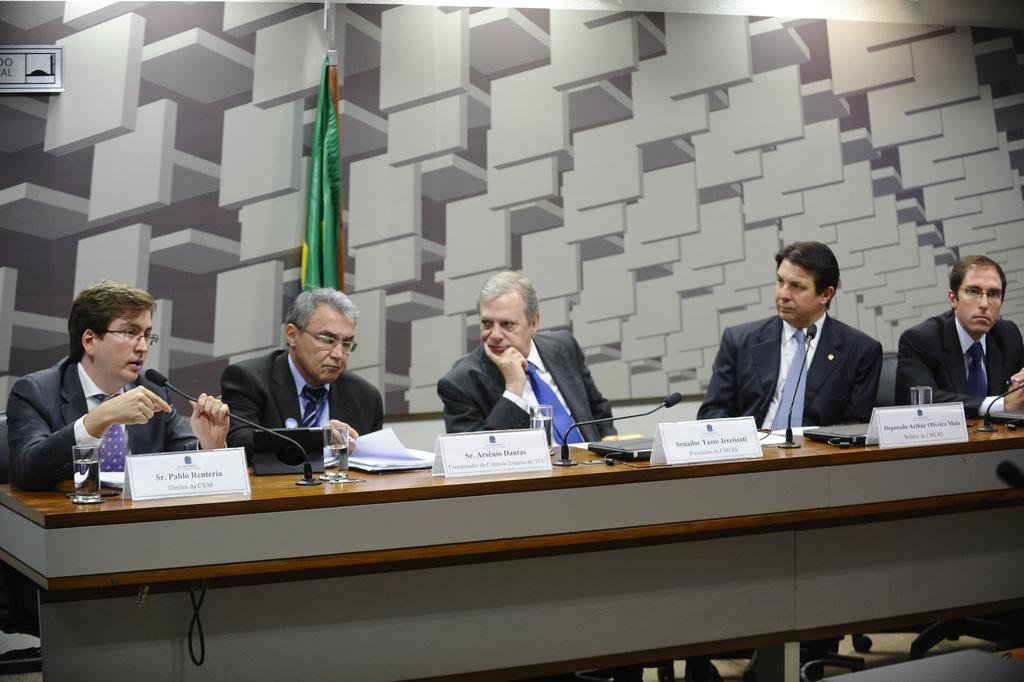Please provide a concise description of this image. There are five persons sitting in a row, wearing suit, tie and white shirt. In front of them, there is a table, name boards, glasses. In the background, there is a flag and wall. 